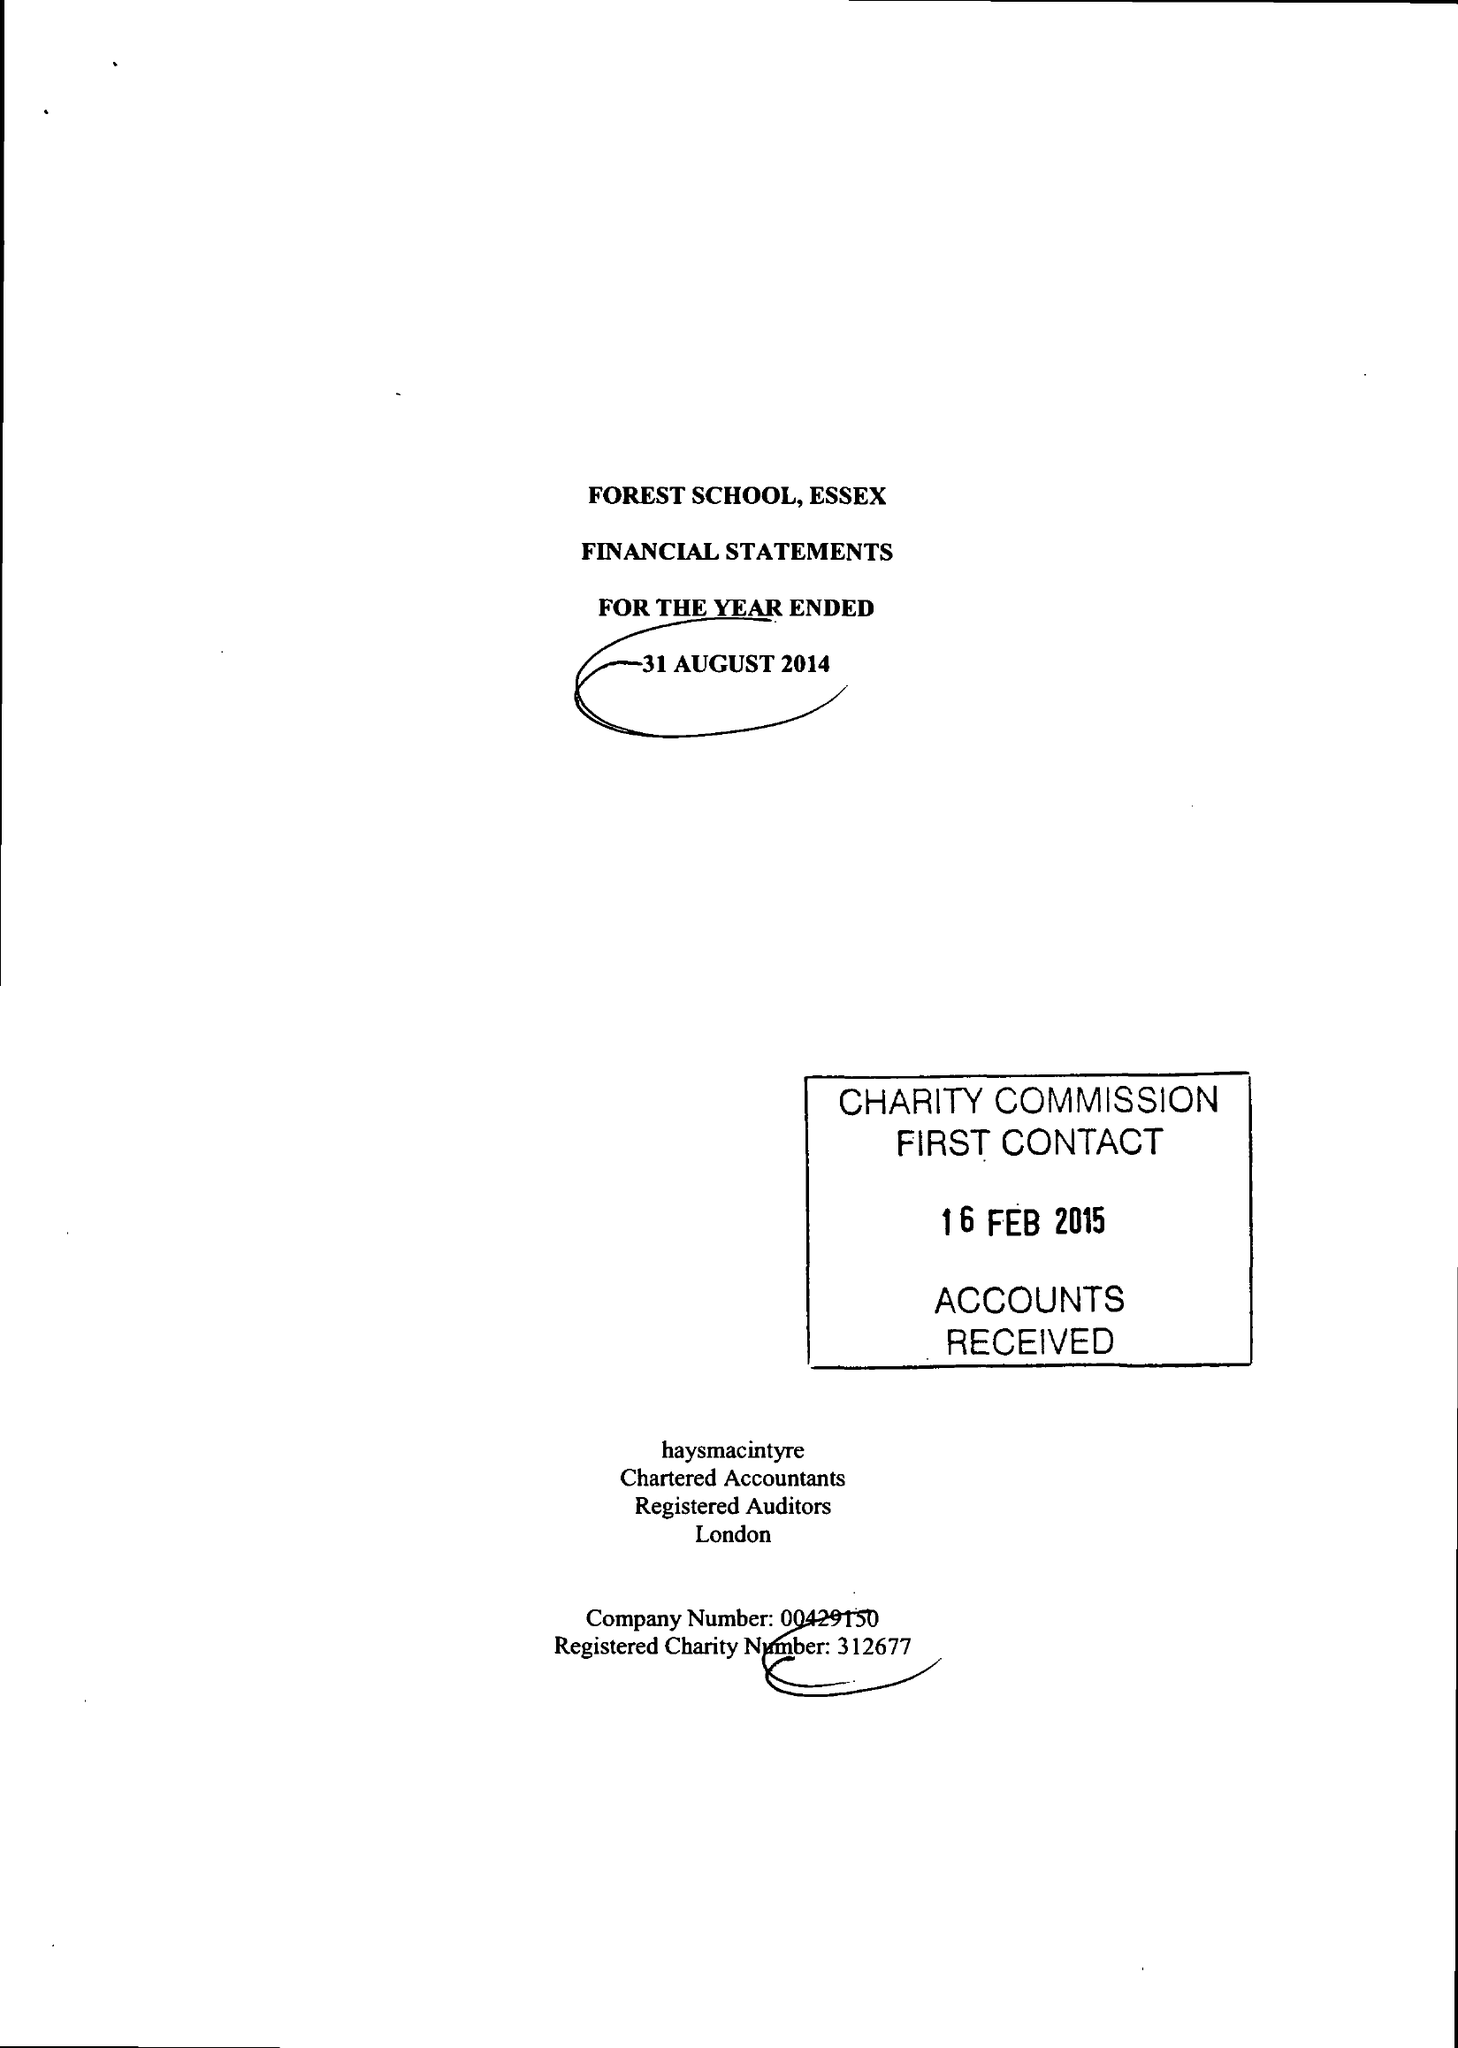What is the value for the address__street_line?
Answer the question using a single word or phrase. COLLEGE PLACE 